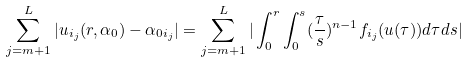<formula> <loc_0><loc_0><loc_500><loc_500>\sum _ { j = m + 1 } ^ { L } | u _ { i _ { j } } ( r , \alpha _ { 0 } ) - \alpha _ { 0 i _ { j } } | & = \sum _ { j = m + 1 } ^ { L } | \int _ { 0 } ^ { r } \int _ { 0 } ^ { s } ( \frac { \tau } { s } ) ^ { n - 1 } f _ { i _ { j } } ( u ( \tau ) ) d \tau d s | \\</formula> 